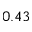Convert formula to latex. <formula><loc_0><loc_0><loc_500><loc_500>0 . 4 3</formula> 